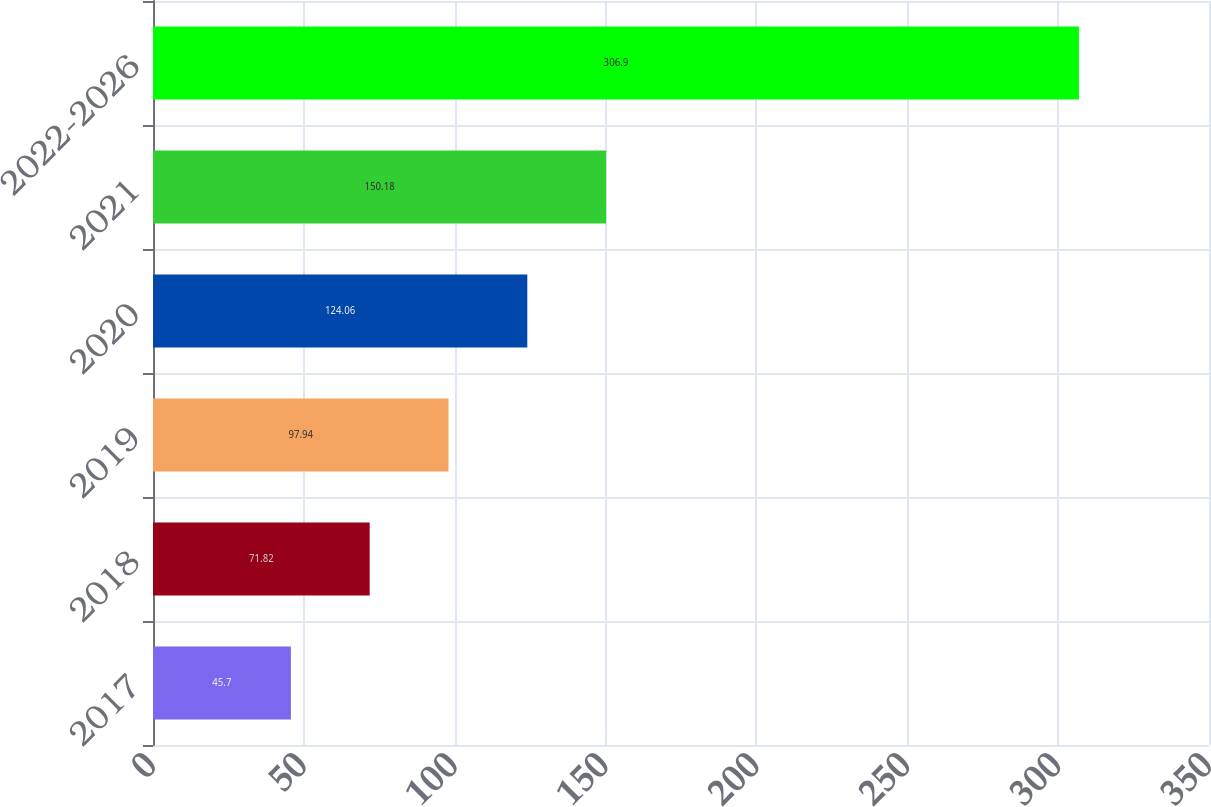<chart> <loc_0><loc_0><loc_500><loc_500><bar_chart><fcel>2017<fcel>2018<fcel>2019<fcel>2020<fcel>2021<fcel>2022-2026<nl><fcel>45.7<fcel>71.82<fcel>97.94<fcel>124.06<fcel>150.18<fcel>306.9<nl></chart> 